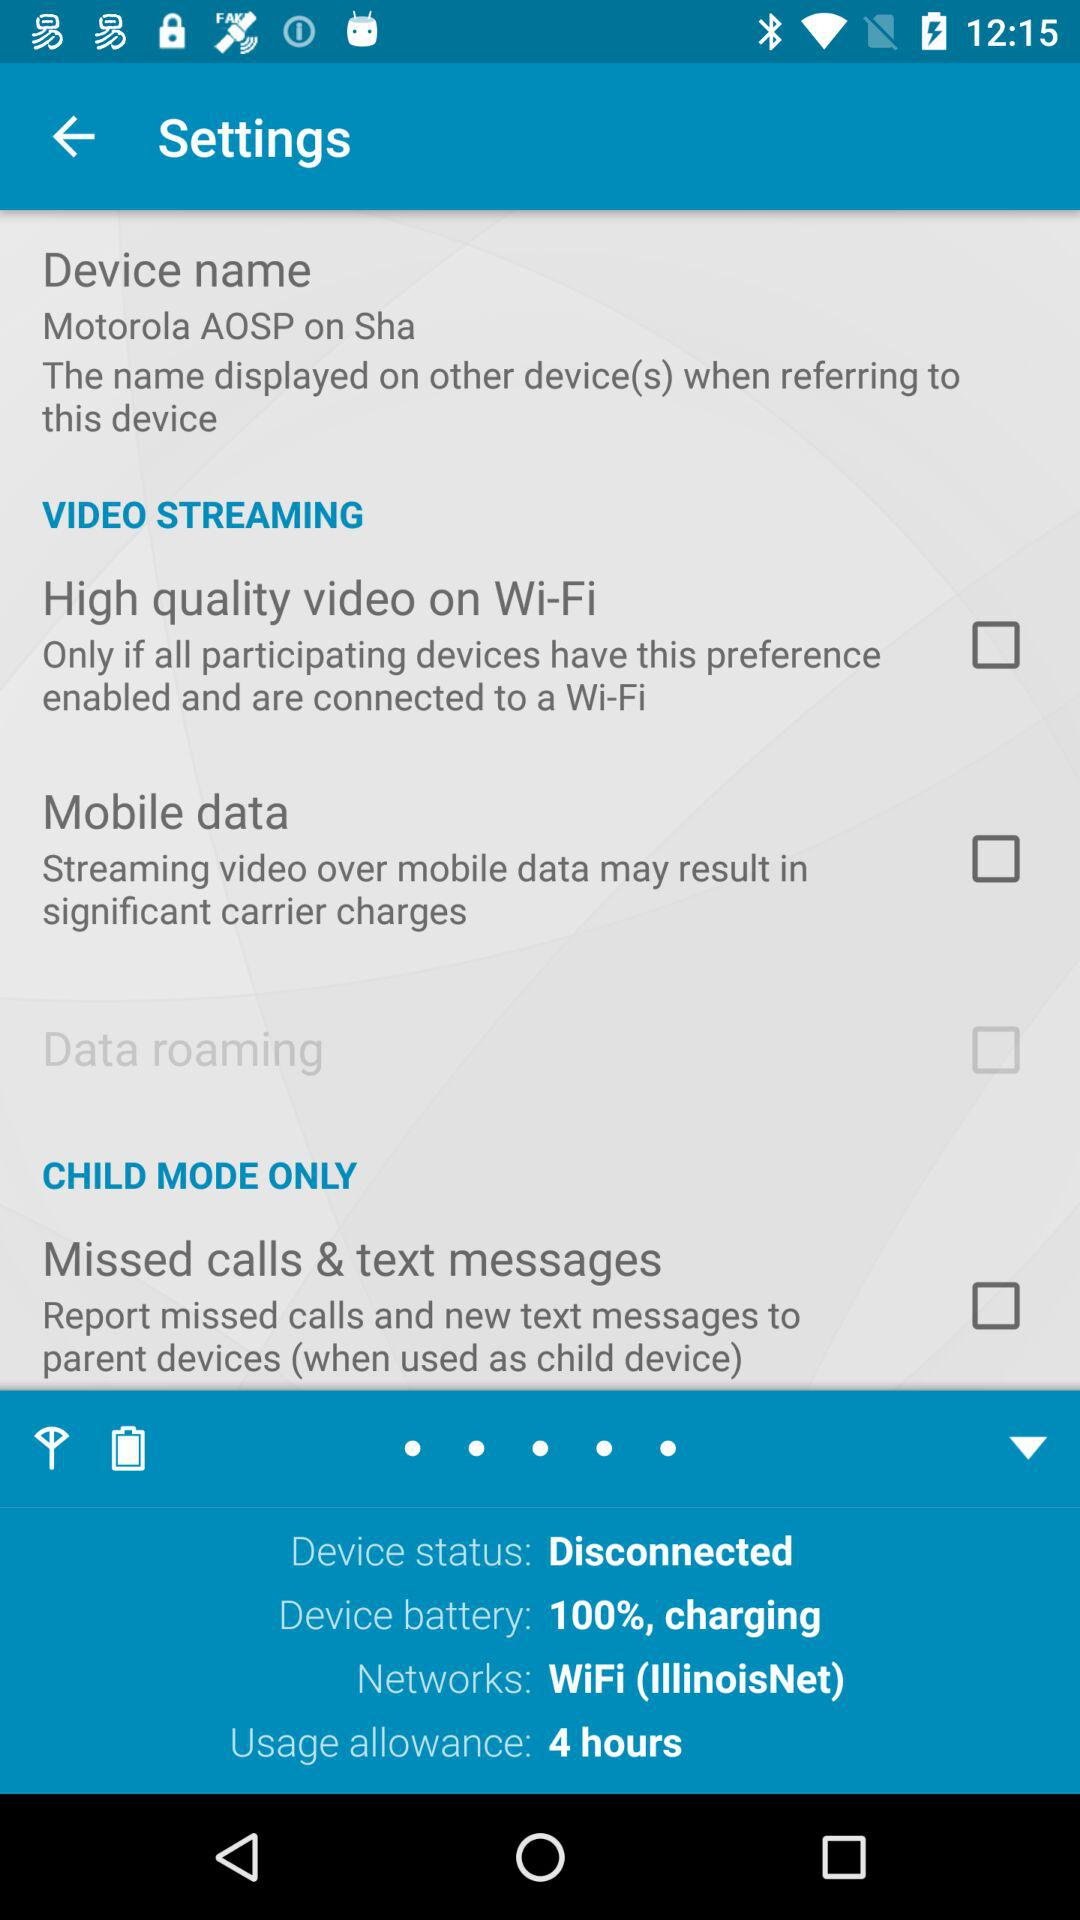How can the high quality video be watched over Wi-Fi? The high quality video can be watched over Wi-Fi only if all participating devices have this preference enabled and are connected to a Wi-Fi. 